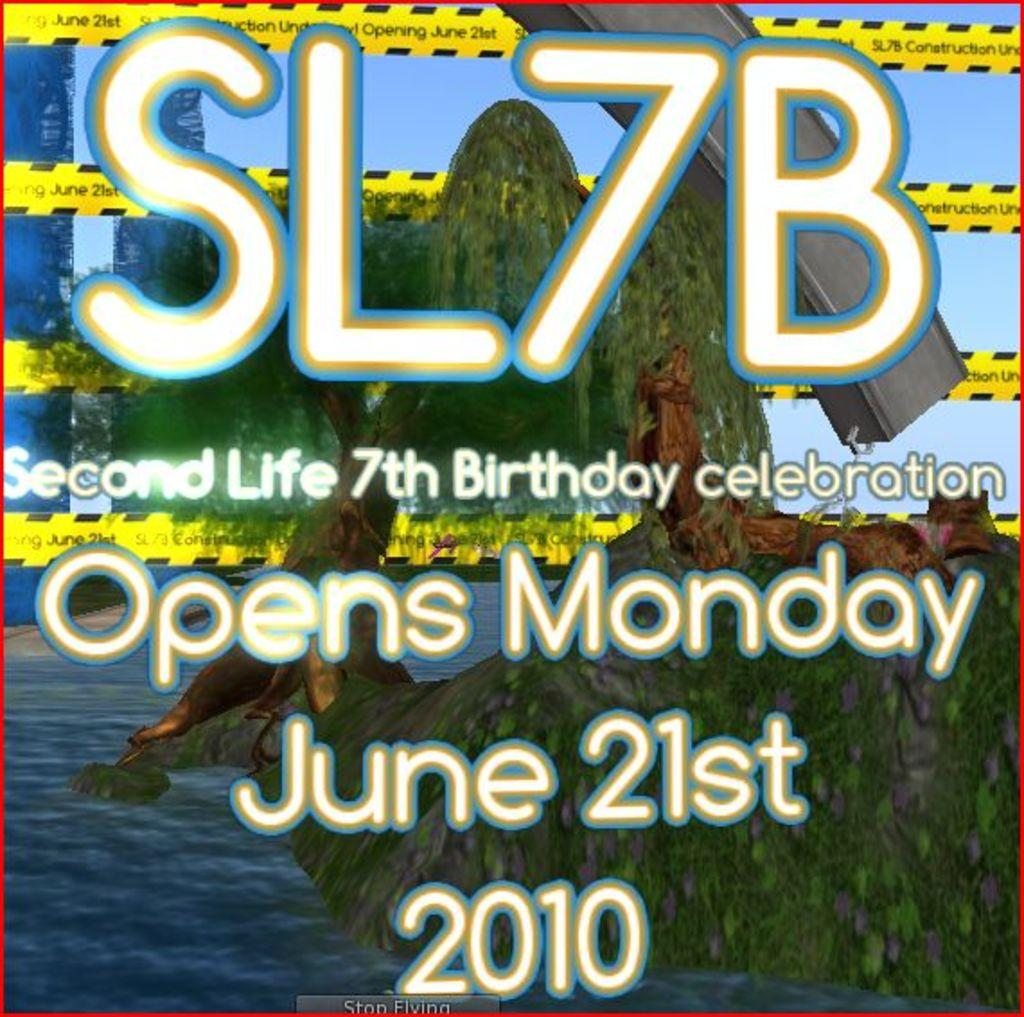What is featured on the poster in the image? There is a poster in the image that contains images of trees and water. Is there any text on the poster? Yes, there is some text on the poster. Can you see a snail crawling on the side of the poster in the image? There is no snail present on the poster or in the image. 